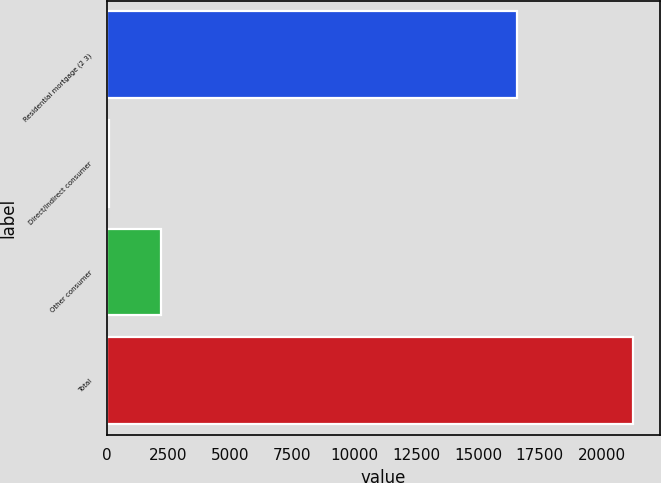<chart> <loc_0><loc_0><loc_500><loc_500><bar_chart><fcel>Residential mortgage (2 3)<fcel>Direct/Indirect consumer<fcel>Other consumer<fcel>Total<nl><fcel>16596<fcel>86<fcel>2206.1<fcel>21287<nl></chart> 